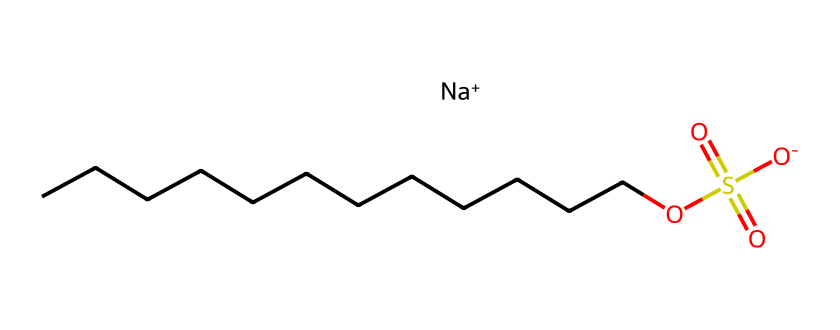What is the chemical name of this structure? The provided SMILES represents sodium lauryl sulfate, where 'sodium' comes from the Na+ and 'lauryl sulfate' refers to the carbon chain and sulfate group.
Answer: sodium lauryl sulfate How many carbon atoms are in sodium lauryl sulfate? Counting the 'C' characters in the chain part of the SMILES before the 'O' indicates there are twelve carbon atoms.
Answer: twelve What functional group is present in this chemical? The presence of the 'OS(=O)(=O)[O-]' part indicates a sulfate group, which is a key functional group in sodium lauryl sulfate.
Answer: sulfate group What type of compound is sodium lauryl sulfate? This compound is an anionic surfactant due to the negatively charged sulfate and its use as a foaming agent in personal care products.
Answer: anionic surfactant How does the chemical structure contribute to its foaming properties? The long hydrophobic carbon chain and the hydrophilic sulfate group create a structure that allows sodium lauryl sulfate to reduce surface tension, facilitating foam formation.
Answer: reduces surface tension How many sulfur atoms are present in sodium lauryl sulfate? The 'S' character in the SMILES indicates there is one sulfur atom in the sulfate group connected to the framework of the molecule.
Answer: one What role does sodium play in this compound? Sodium serves as a counterion to neutralize the negative charge of the sulfate group, making the compound stable and soluble in water.
Answer: counterion 